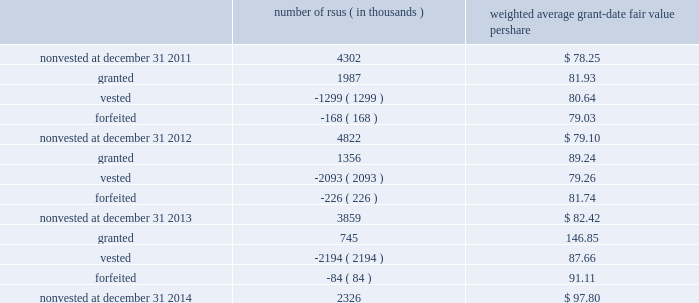Note 11 2013 stock-based compensation during 2014 , 2013 and 2012 , we recorded non-cash stock-based compensation expense totaling $ 164 million , $ 189 million and $ 167 million , which is included as a component of other unallocated , net on our statements of earnings .
The net impact to earnings for the respective years was $ 107 million , $ 122 million and $ 108 million .
As of december 31 , 2014 , we had $ 91 million of unrecognized compensation cost related to nonvested awards , which is expected to be recognized over a weighted average period of 1.6 years .
We received cash from the exercise of stock options totaling $ 308 million , $ 827 million and $ 440 million during 2014 , 2013 and 2012 .
In addition , our income tax liabilities for 2014 , 2013 and 2012 were reduced by $ 215 million , $ 158 million , $ 96 million due to recognized tax benefits on stock-based compensation arrangements .
Stock-based compensation plans under plans approved by our stockholders , we are authorized to grant key employees stock-based incentive awards , including options to purchase common stock , stock appreciation rights , restricted stock units ( rsus ) , performance stock units ( psus ) or other stock units .
The exercise price of options to purchase common stock may not be less than the fair market value of our stock on the date of grant .
No award of stock options may become fully vested prior to the third anniversary of the grant and no portion of a stock option grant may become vested in less than one year .
The minimum vesting period for restricted stock or stock units payable in stock is three years .
Award agreements may provide for shorter or pro-rated vesting periods or vesting following termination of employment in the case of death , disability , divestiture , retirement , change of control or layoff .
The maximum term of a stock option or any other award is 10 years .
At december 31 , 2014 , inclusive of the shares reserved for outstanding stock options , rsus and psus , we had 19 million shares reserved for issuance under the plans .
At december 31 , 2014 , 7.8 million of the shares reserved for issuance remained available for grant under our stock-based compensation plans .
We issue new shares upon the exercise of stock options or when restrictions on rsus and psus have been satisfied .
The table summarizes activity related to nonvested rsus during 2014 : number of rsus ( in thousands ) weighted average grant-date fair value per share .
Rsus are valued based on the fair value of our common stock on the date of grant .
Employees who are granted rsus receive the right to receive shares of stock after completion of the vesting period ; however , the shares are not issued and the employees cannot sell or transfer shares prior to vesting and have no voting rights until the rsus vest , generally three years from the date of the award .
Employees who are granted rsus receive dividend-equivalent cash payments only upon vesting .
For these rsu awards , the grant-date fair value is equal to the closing market price of our common stock on the date of grant less a discount to reflect the delay in payment of dividend-equivalent cash payments .
We recognize the grant-date fair value of rsus , less estimated forfeitures , as compensation expense ratably over the requisite service period , which beginning with the rsus granted in 2013 is shorter than the vesting period if the employee is retirement eligible on the date of grant or will become retirement eligible before the end of the vesting period. .
What was the percentage change in non-cash stock-based compensation expense from 2012 to 2013? 
Computations: ((189 - 167) / 167)
Answer: 0.13174. 